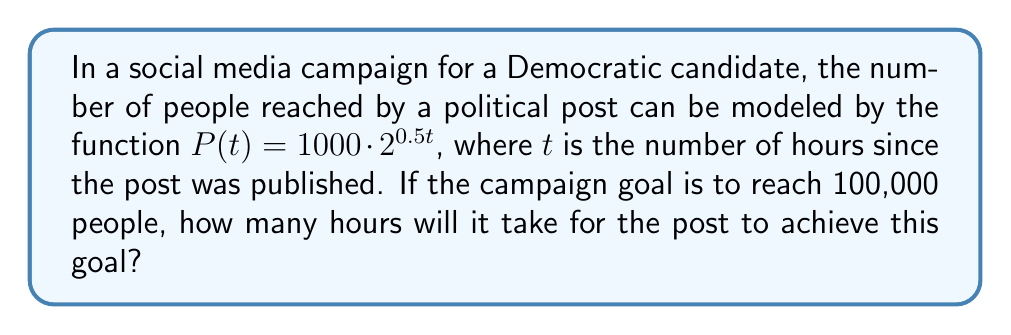Can you answer this question? Let's approach this step-by-step:

1) We're given the function $P(t) = 1000 \cdot 2^{0.5t}$, where $P(t)$ is the number of people reached after $t$ hours.

2) We want to find $t$ when $P(t) = 100,000$. So, let's set up the equation:

   $100,000 = 1000 \cdot 2^{0.5t}$

3) Divide both sides by 1000:

   $100 = 2^{0.5t}$

4) Now, we can take the logarithm (base 2) of both sides:

   $\log_2(100) = \log_2(2^{0.5t})$

5) The right side simplifies due to the logarithm rule $\log_a(a^x) = x$:

   $\log_2(100) = 0.5t$

6) We can calculate $\log_2(100)$:

   $\log_2(100) = \frac{\log(100)}{\log(2)} \approx 6.643856$

7) So our equation is now:

   $6.643856 = 0.5t$

8) Multiply both sides by 2:

   $13.287712 = t$

9) Rounding to the nearest hour (since we're dealing with whole hours), we get 13 hours.
Answer: 13 hours 